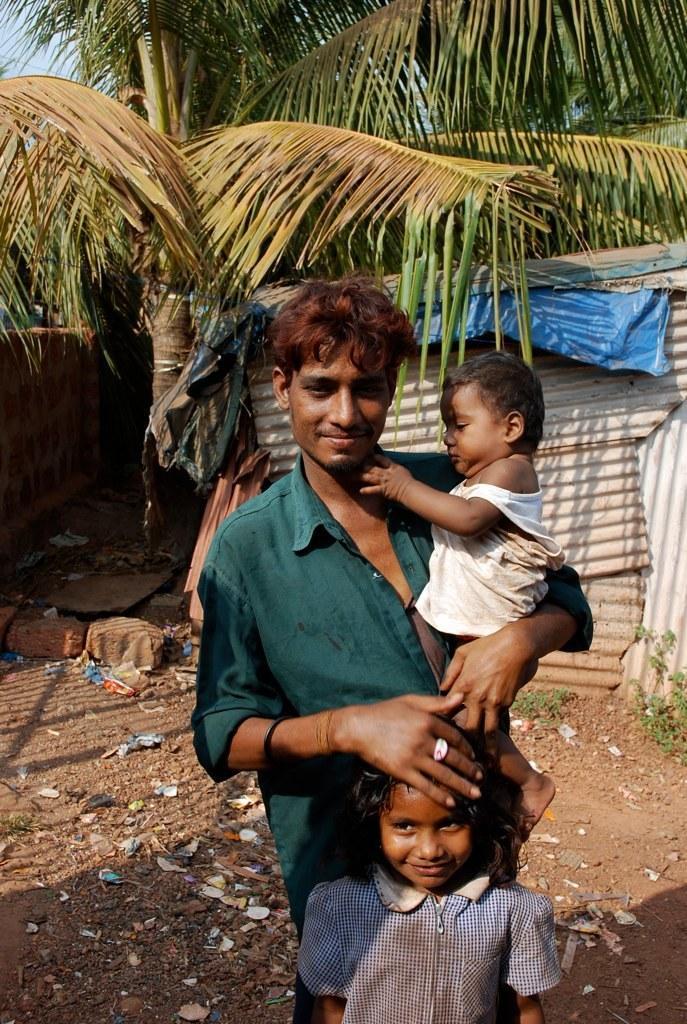Describe this image in one or two sentences. Here a man is holding a kid in his hand and a girl standing at him. In the background there is a small house,trees and sky. 